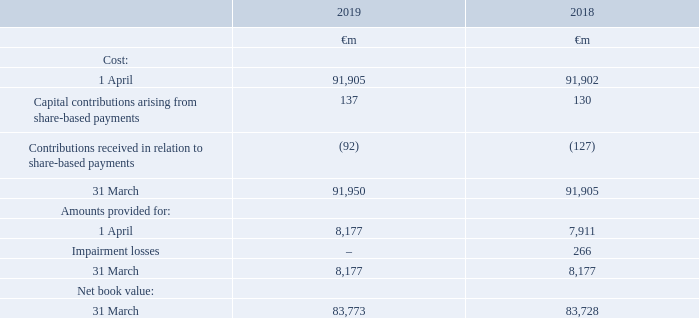2. Fixed assets
Accounting policies
Shares in Group undertakings are stated at cost less any provision for impairment and capital related to share-based payments. Contributions in respect of share-based payments are recognised in line with the policy set out in note 7 “Share-based payments”.
The Company assesses investments for impairment whenever events or changes in circumstances indicate that the carrying value of an investment may not be recoverable. If any such indication of impairment exists, the Company makes an estimate of the recoverable amount. If the recoverable amount of the cash-generating unit is less than the value of the investment, the investment is considered to be impaired and is written down to its recoverable amount. An impairment loss is recognised immediately in the income statement.
Shares in Group undertakings
Which financial years' information is shown in the table? 2018, 2019. What is the net book value as of 31 March in 2019?
Answer scale should be: million. 83,773. Which financial items does the cost as at 31 March 2019 comprise of? 1 april, capital contributions arising from share-based payments, contributions received in relation to share-based payments. What is the 2019 average net book value as at 31 March ?
Answer scale should be: million. (83,773+83,728)/2
Answer: 83750.5. What is the 2019 average total cost of shares in Group undertakings as at 31 March?
Answer scale should be: million. (91,950+91,905)/2
Answer: 91927.5. What is the difference between 2019 average net book value and 2019 average total costs of shares in Group undertakings as at 31 March?
Answer scale should be: million. [(91,950+91,905)/2] - [(83,773+83,728)/2]
Answer: 8177. 